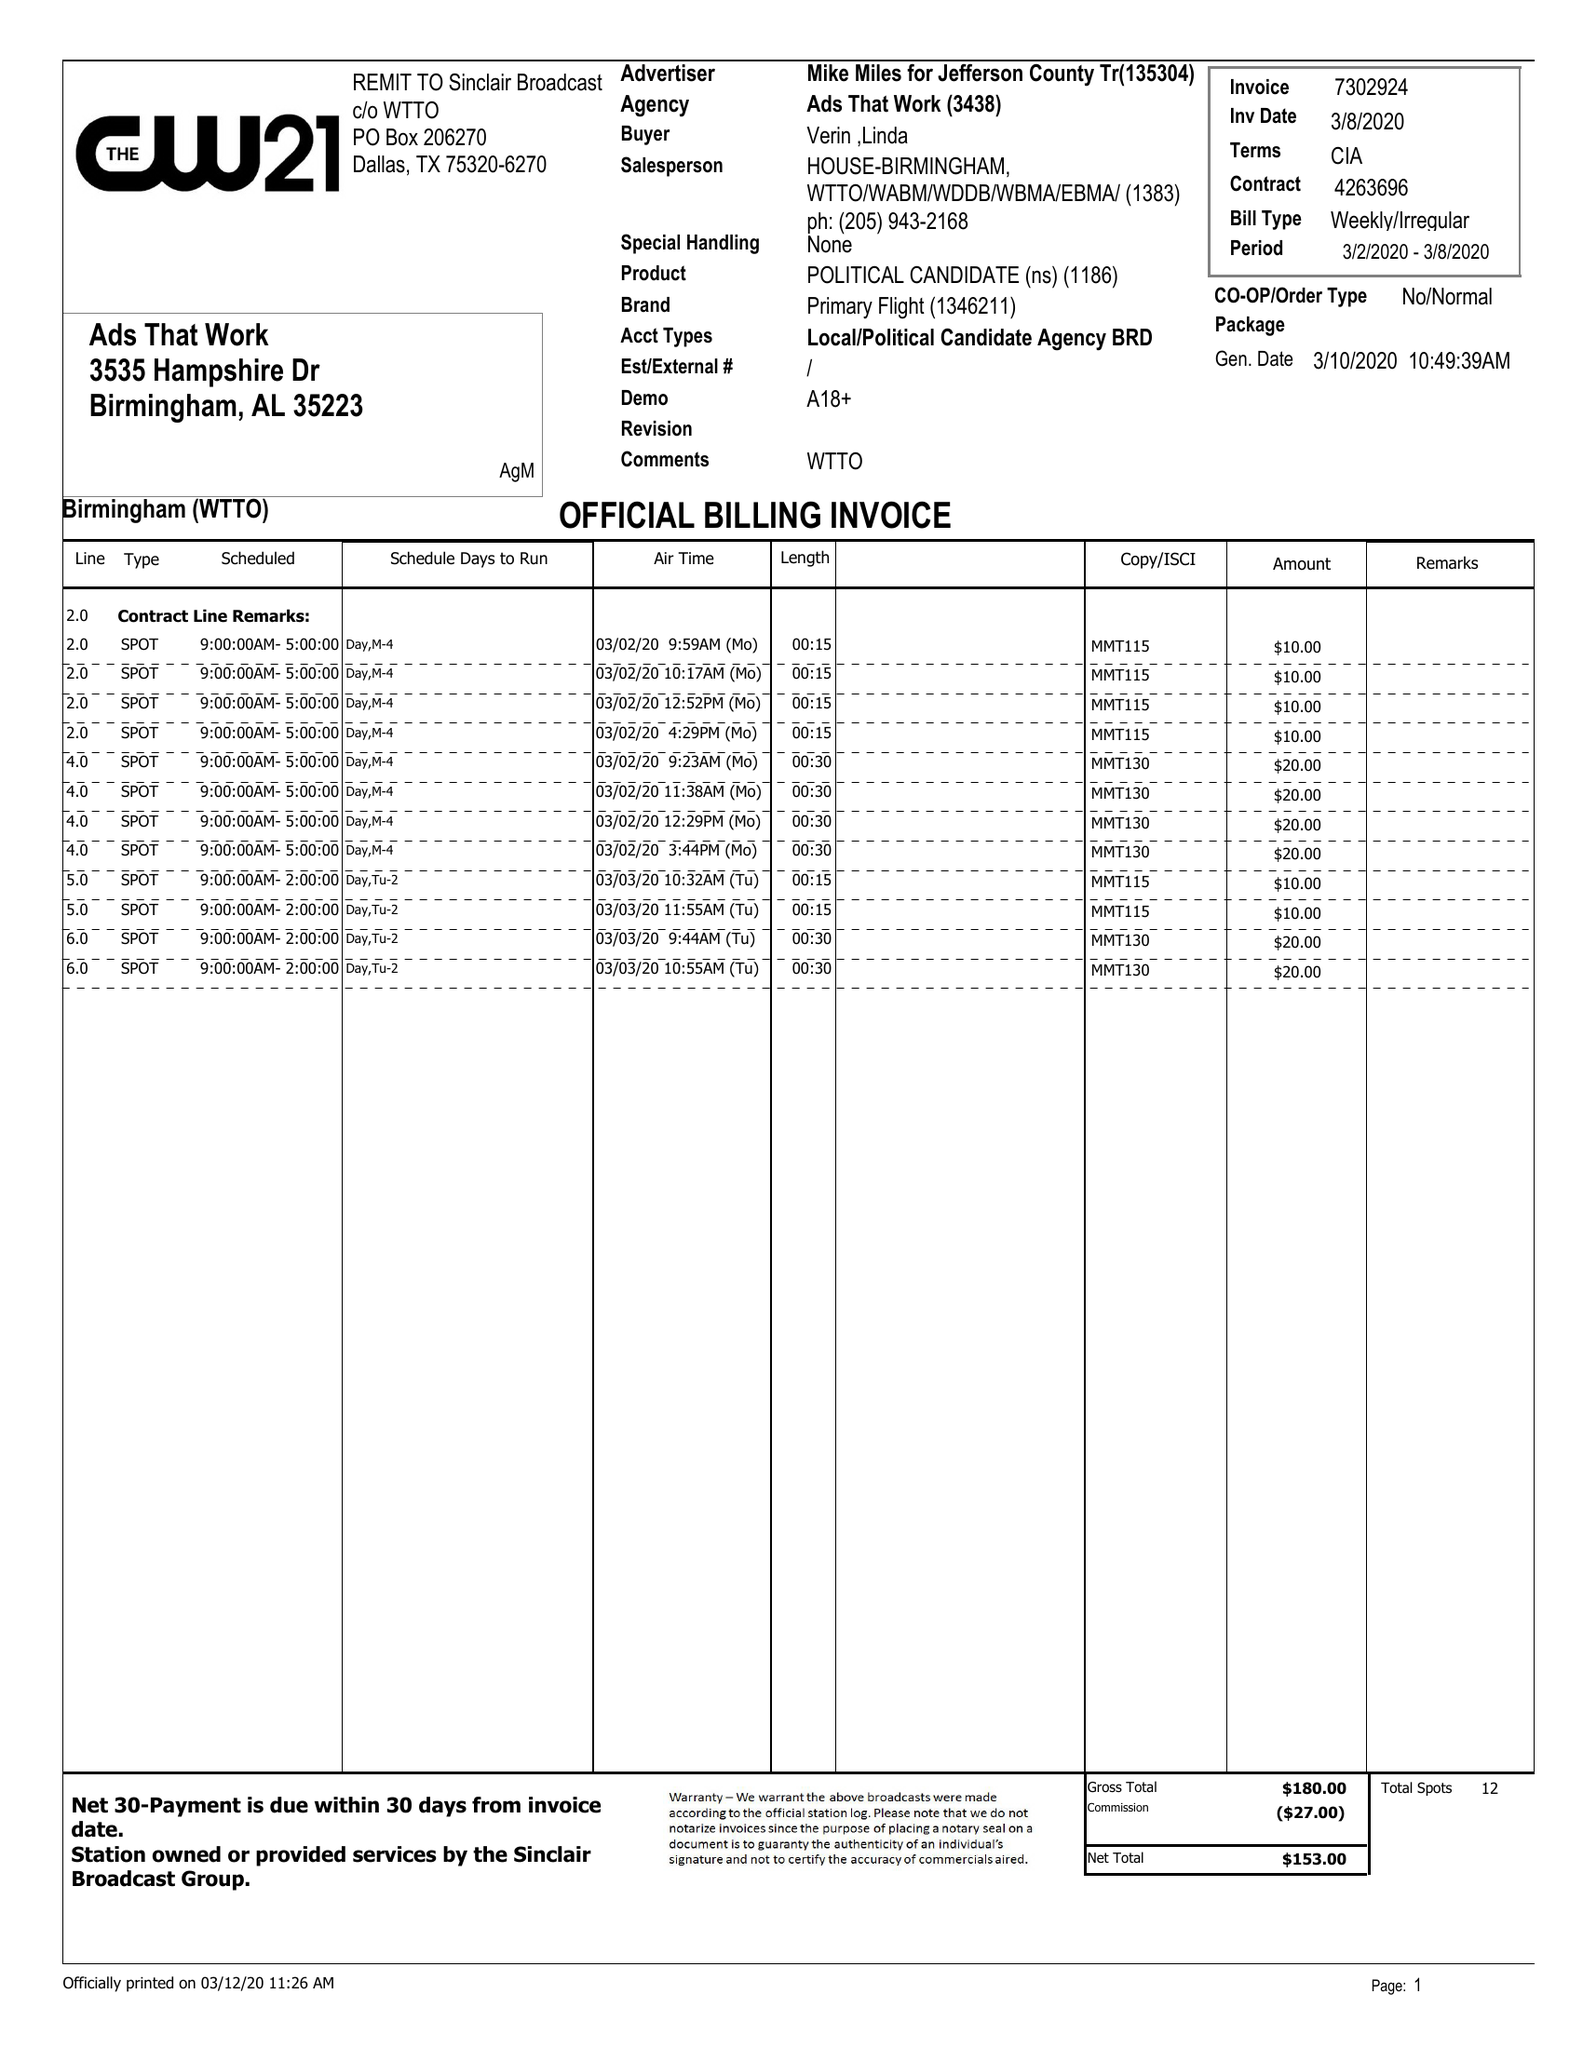What is the value for the contract_num?
Answer the question using a single word or phrase. 4263696 